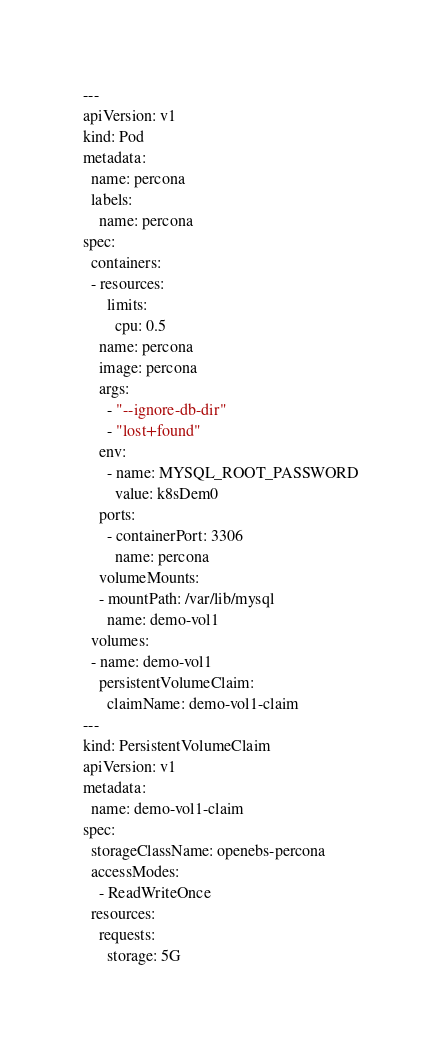<code> <loc_0><loc_0><loc_500><loc_500><_YAML_>---
apiVersion: v1
kind: Pod
metadata:
  name: percona
  labels:
    name: percona
spec:
  containers:
  - resources:
      limits:
        cpu: 0.5
    name: percona
    image: percona
    args:
      - "--ignore-db-dir"
      - "lost+found"
    env:
      - name: MYSQL_ROOT_PASSWORD
        value: k8sDem0
    ports:
      - containerPort: 3306
        name: percona
    volumeMounts:
    - mountPath: /var/lib/mysql
      name: demo-vol1
  volumes:
  - name: demo-vol1
    persistentVolumeClaim:
      claimName: demo-vol1-claim
---
kind: PersistentVolumeClaim
apiVersion: v1
metadata:
  name: demo-vol1-claim
spec:
  storageClassName: openebs-percona
  accessModes:
    - ReadWriteOnce
  resources:
    requests:
      storage: 5G

</code> 